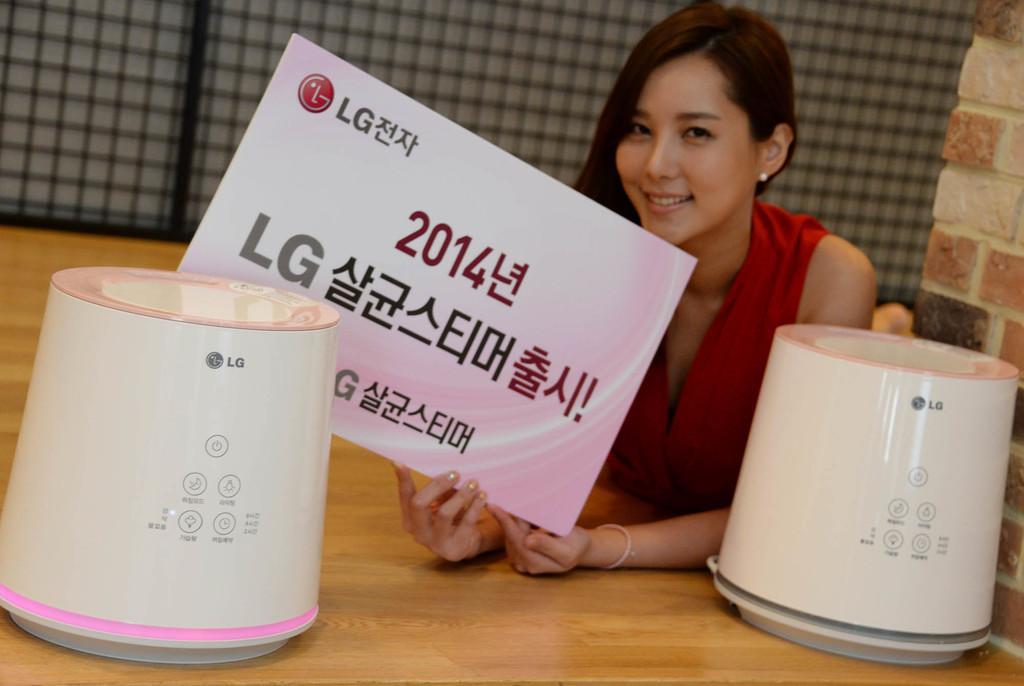Can you describe this image briefly? In this image we can see a woman smiling and holding the LG board with text. We can also see two LG objects on the wooden table. In the background we can see the fence. On the right there is a brick wall. 